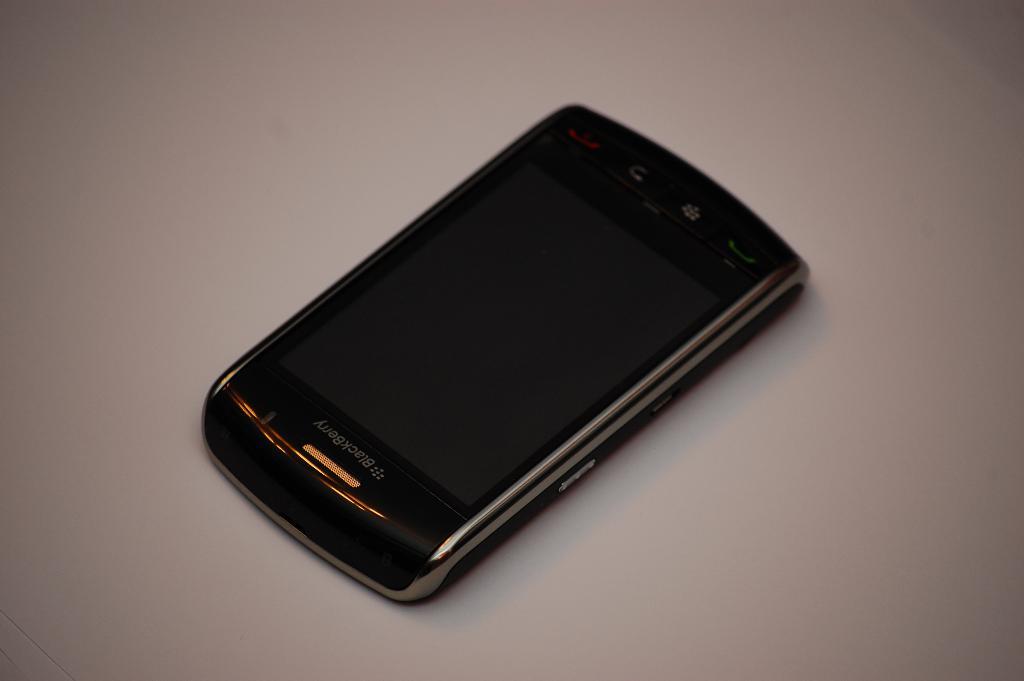What type of phone is that?
Keep it short and to the point. Blackberry. 